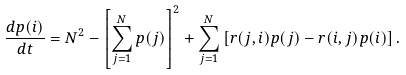<formula> <loc_0><loc_0><loc_500><loc_500>\frac { d p ( i ) } { d t } = N ^ { 2 } - \left [ \sum _ { j = 1 } ^ { N } p ( j ) \right ] ^ { 2 } + \sum _ { j = 1 } ^ { N } \left [ r ( j , i ) p ( j ) - r ( i , j ) p ( i ) \right ] .</formula> 